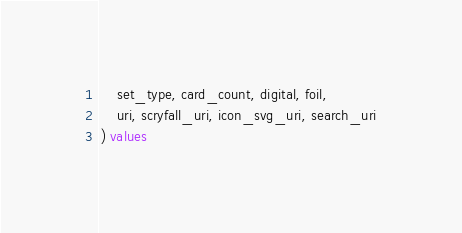Convert code to text. <code><loc_0><loc_0><loc_500><loc_500><_SQL_>    set_type, card_count, digital, foil,
    uri, scryfall_uri, icon_svg_uri, search_uri
) values </code> 